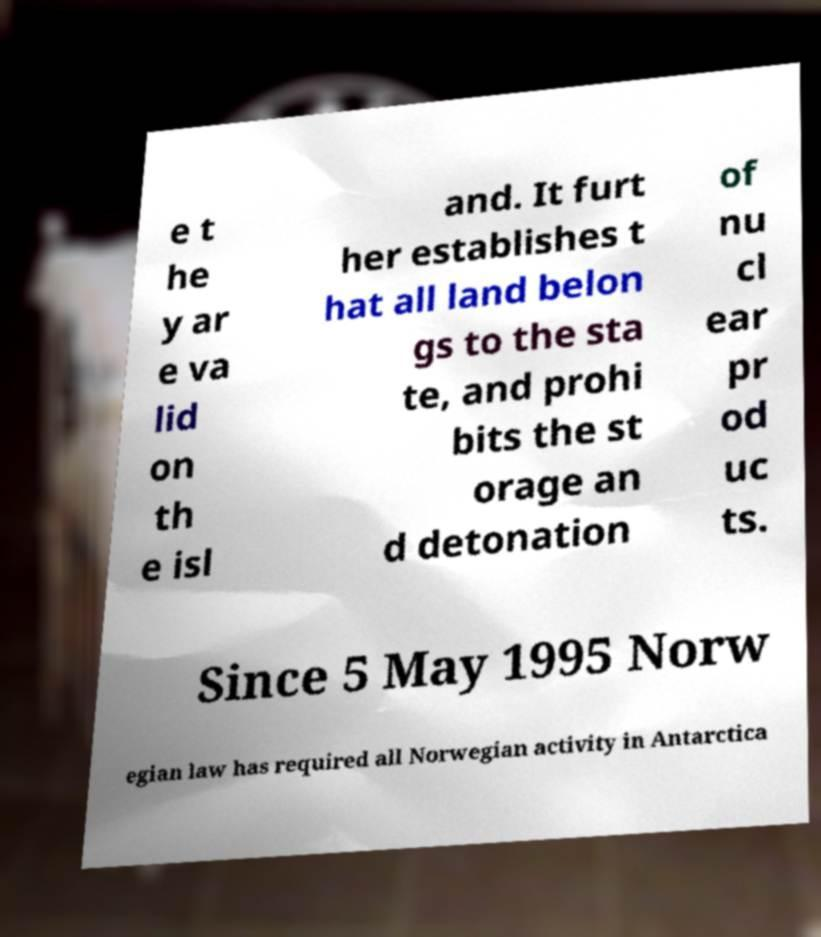Could you assist in decoding the text presented in this image and type it out clearly? e t he y ar e va lid on th e isl and. It furt her establishes t hat all land belon gs to the sta te, and prohi bits the st orage an d detonation of nu cl ear pr od uc ts. Since 5 May 1995 Norw egian law has required all Norwegian activity in Antarctica 